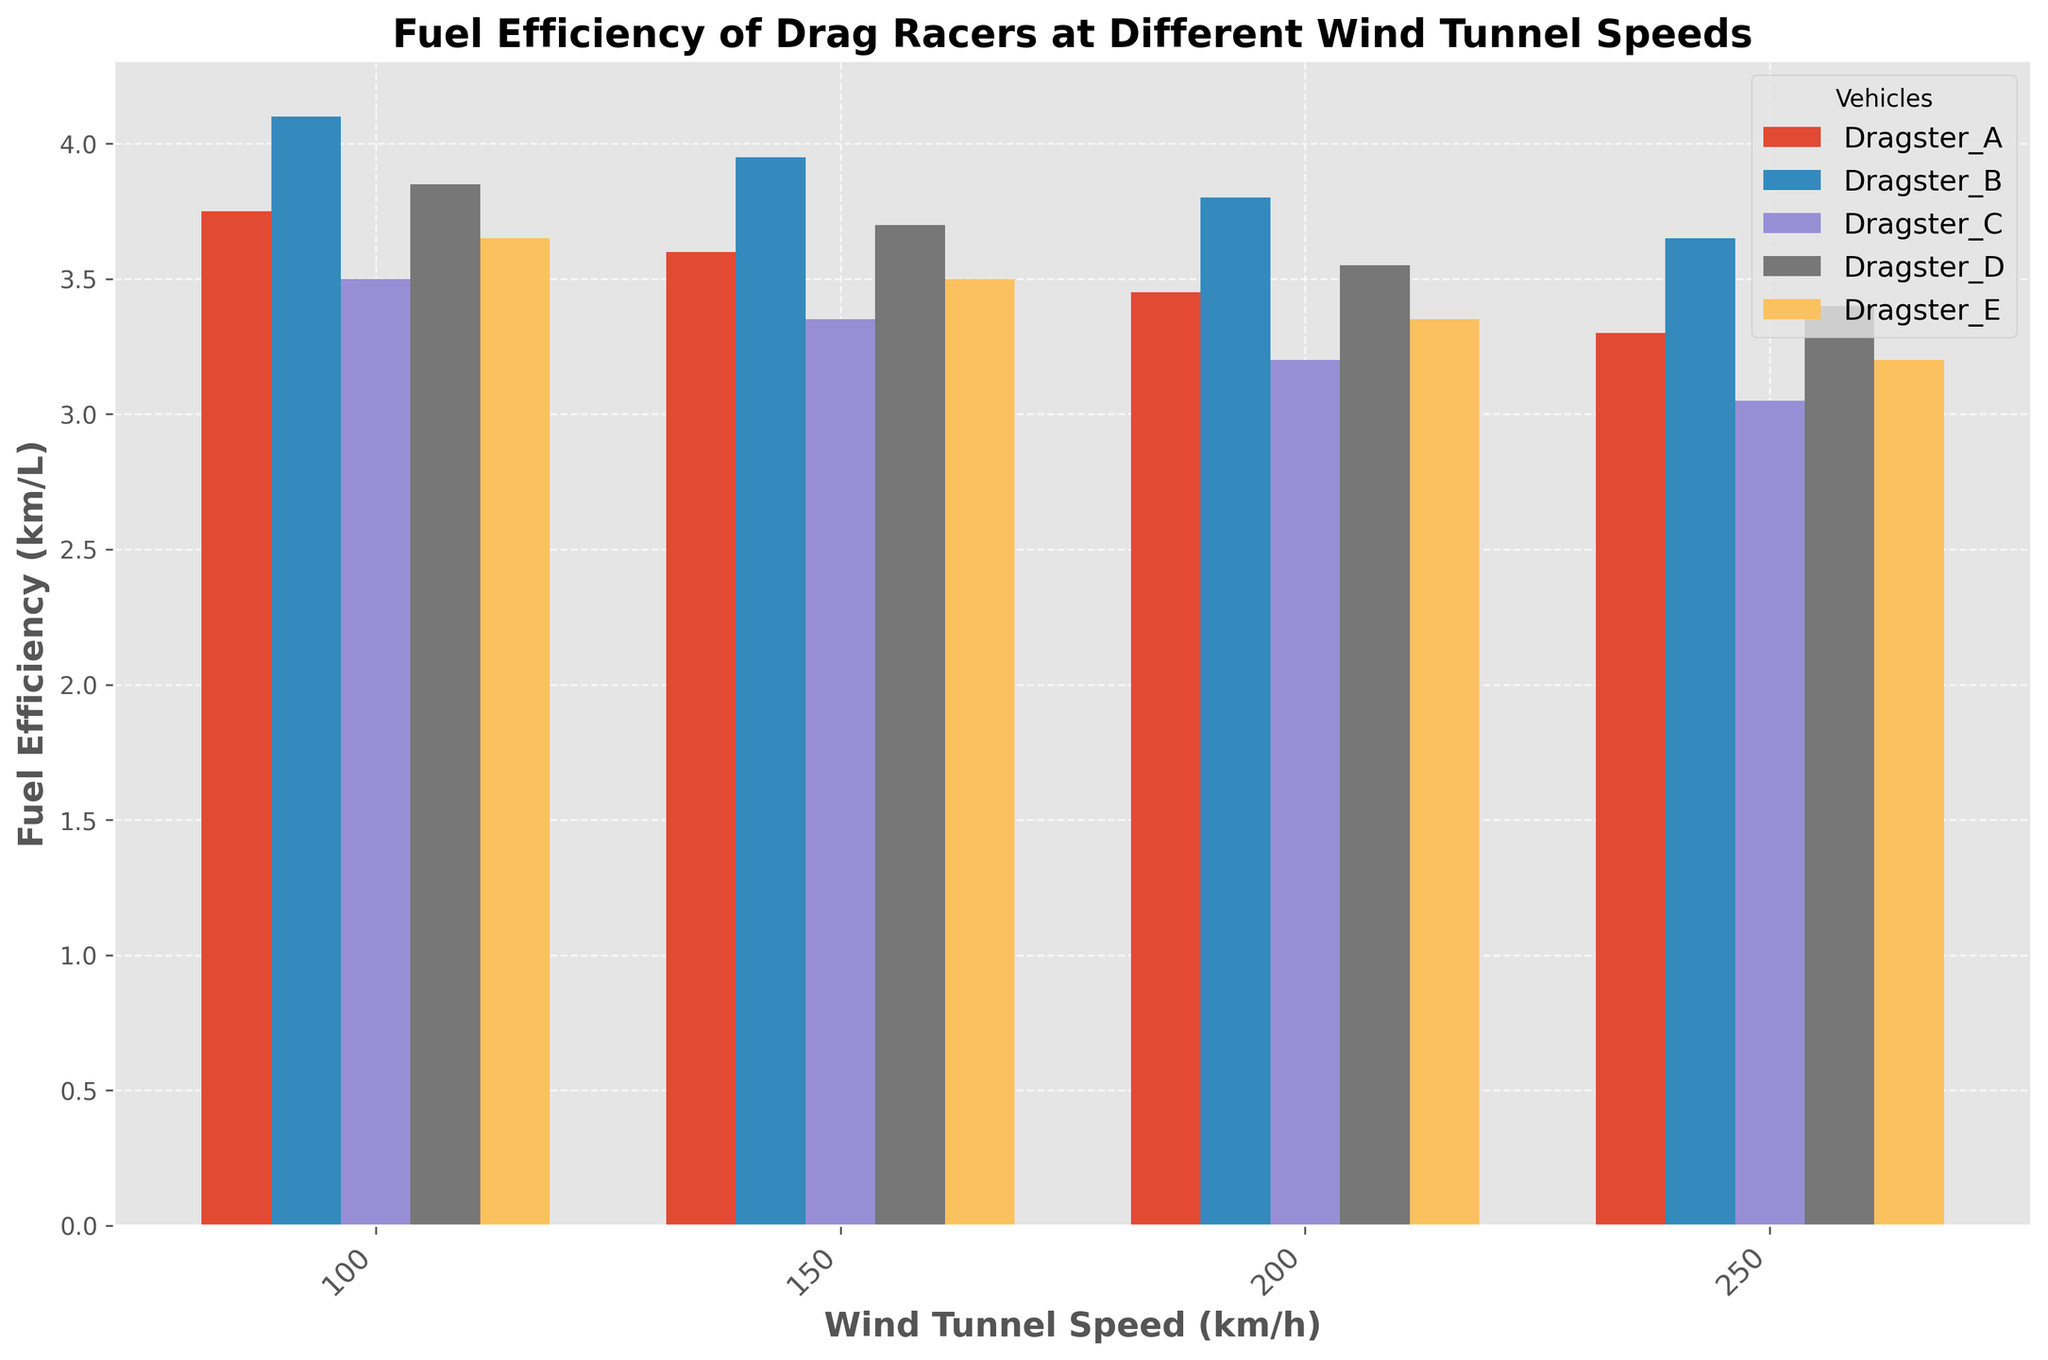Which vehicle has the highest fuel efficiency at 150 km/h? By looking at the bar heights for different vehicles at the 150 km/h wind tunnel speed, we find that Dragster_B has the highest bar, indicating the highest fuel efficiency.
Answer: Dragster_B Which vehicle has the lowest fuel efficiency at 250 km/h? By observing the bars corresponding to the 250 km/h speed, Dragster_C shows the lowest bar height, indicating the lowest fuel efficiency at that speed.
Answer: Dragster_C What is the average fuel efficiency of Dragster_A across all speeds? To calculate the average fuel efficiency of Dragster_A, sum its efficiencies at all speeds (3.75 + 3.60 + 3.45 + 3.30) = 14.10 and then divide by the number of speeds (4). The average efficiency is 14.10 / 4 = 3.525
Answer: 3.525 Which vehicle shows the most consistent fuel efficiency across different speeds? Consistency can be determined by comparing the variations in bar heights across speeds for each vehicle. By visual inspection, Dragster_B has the smallest variation in bar heights.
Answer: Dragster_B At 200 km/h, which vehicle is the second most fuel-efficient? By examining the bar heights at 200 km/h, Dragster_B has the highest bar, followed by Dragster_D, making Dragster_D the second most efficient vehicle at this speed.
Answer: Dragster_D What is the difference in efficiency between Dragster_A and Dragster_C at 150 km/h? The fuel efficiency of Dragster_A at 150 km/h is 3.60, and Dragster_C is 3.35. The difference is calculated as 3.60 - 3.35 = 0.25
Answer: 0.25 Which vehicle's fuel efficiency decreases the most from 100 km/h to 250 km/h? By comparing the drop in bar heights from 100 km/h to 250 km/h for each vehicle, Dragster_C shows the largest decrease (3.50 - 3.05 = 0.45)
Answer: Dragster_C Between Dragster_B and Dragster_D, which one has a higher efficiency at 200 km/h, and by how much? Dragster_B has an efficiency of 3.80 at 200 km/h, and Dragster_D has 3.55. The difference is 3.80 - 3.55 = 0.25
Answer: Dragster_B by 0.25 What is the average fuel efficiency for all vehicles at 100 km/h? Summing the efficiencies at 100 km/h across all vehicles (3.75 + 4.10 + 3.50 + 3.85 + 3.65) = 18.85 and dividing by the number of vehicles (5) gives the average as 18.85 / 5 = 3.77
Answer: 3.77 